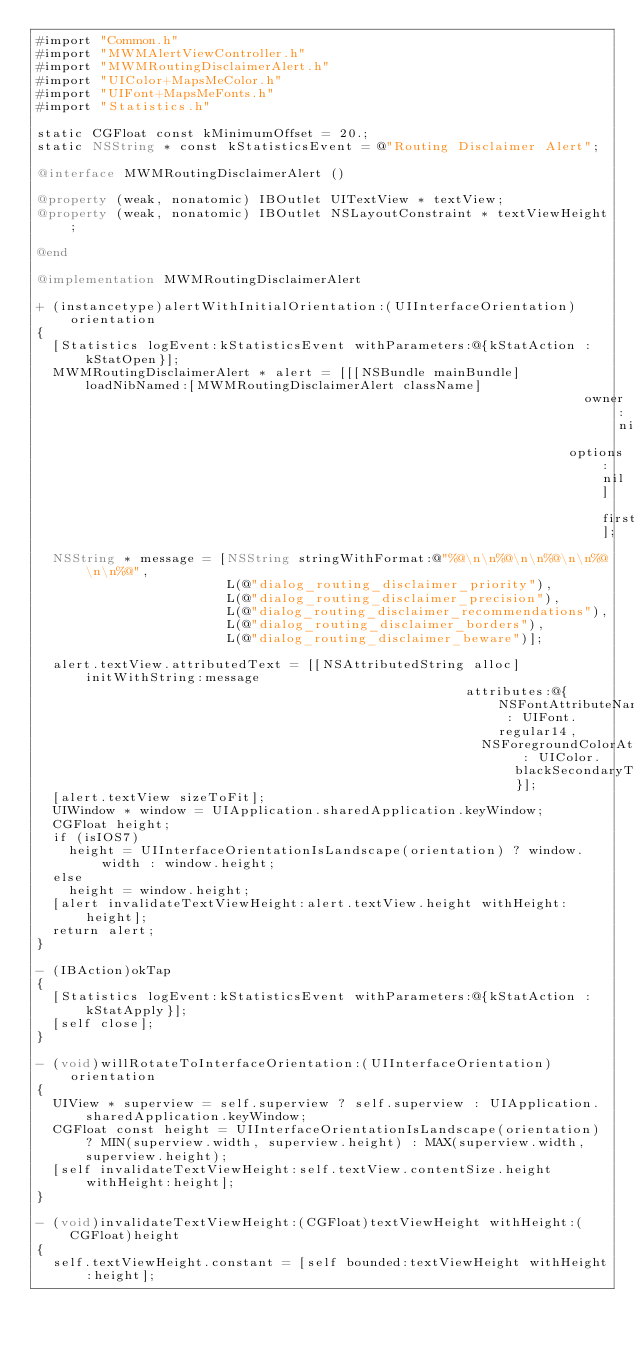<code> <loc_0><loc_0><loc_500><loc_500><_ObjectiveC_>#import "Common.h"
#import "MWMAlertViewController.h"
#import "MWMRoutingDisclaimerAlert.h"
#import "UIColor+MapsMeColor.h"
#import "UIFont+MapsMeFonts.h"
#import "Statistics.h"

static CGFloat const kMinimumOffset = 20.;
static NSString * const kStatisticsEvent = @"Routing Disclaimer Alert";

@interface MWMRoutingDisclaimerAlert ()

@property (weak, nonatomic) IBOutlet UITextView * textView;
@property (weak, nonatomic) IBOutlet NSLayoutConstraint * textViewHeight;

@end

@implementation MWMRoutingDisclaimerAlert

+ (instancetype)alertWithInitialOrientation:(UIInterfaceOrientation)orientation
{
  [Statistics logEvent:kStatisticsEvent withParameters:@{kStatAction : kStatOpen}];
  MWMRoutingDisclaimerAlert * alert = [[[NSBundle mainBundle] loadNibNamed:[MWMRoutingDisclaimerAlert className]
                                                                     owner:nil
                                                                   options:nil] firstObject];
  NSString * message = [NSString stringWithFormat:@"%@\n\n%@\n\n%@\n\n%@\n\n%@",
                        L(@"dialog_routing_disclaimer_priority"),
                        L(@"dialog_routing_disclaimer_precision"),
                        L(@"dialog_routing_disclaimer_recommendations"),
                        L(@"dialog_routing_disclaimer_borders"),
                        L(@"dialog_routing_disclaimer_beware")];

  alert.textView.attributedText = [[NSAttributedString alloc] initWithString:message
                                                      attributes:@{NSFontAttributeName : UIFont.regular14,
                                                        NSForegroundColorAttributeName : UIColor.blackSecondaryText}];
  [alert.textView sizeToFit];
  UIWindow * window = UIApplication.sharedApplication.keyWindow;
  CGFloat height;
  if (isIOS7)
    height = UIInterfaceOrientationIsLandscape(orientation) ? window.width : window.height;
  else
    height = window.height;
  [alert invalidateTextViewHeight:alert.textView.height withHeight:height];
  return alert;
}

- (IBAction)okTap
{
  [Statistics logEvent:kStatisticsEvent withParameters:@{kStatAction : kStatApply}];
  [self close];
}

- (void)willRotateToInterfaceOrientation:(UIInterfaceOrientation)orientation
{
  UIView * superview = self.superview ? self.superview : UIApplication.sharedApplication.keyWindow;
  CGFloat const height = UIInterfaceOrientationIsLandscape(orientation) ? MIN(superview.width, superview.height) : MAX(superview.width, superview.height);
  [self invalidateTextViewHeight:self.textView.contentSize.height withHeight:height];
}

- (void)invalidateTextViewHeight:(CGFloat)textViewHeight withHeight:(CGFloat)height
{
  self.textViewHeight.constant = [self bounded:textViewHeight withHeight:height];</code> 